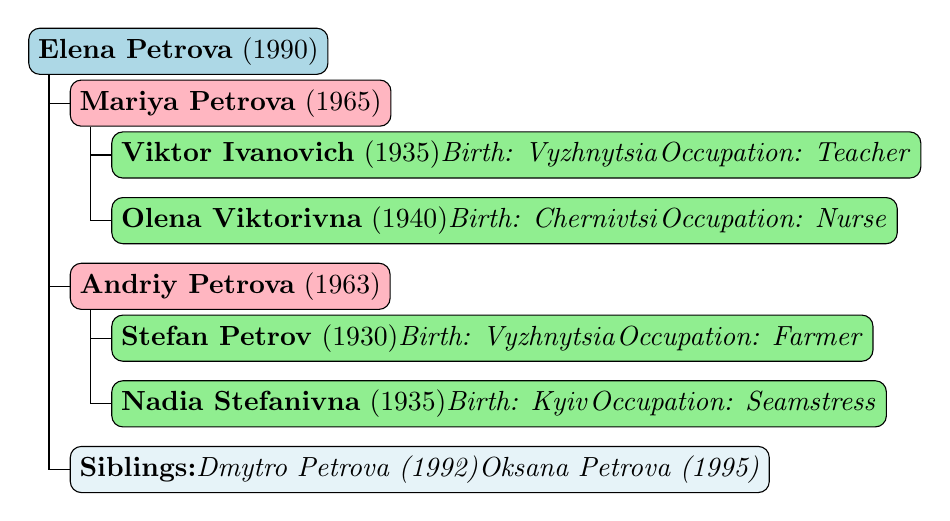What is the birth year of Elena Petrova? The table clearly shows that Elena Petrova was born in 1990.
Answer: 1990 Who are the parents of Elena Petrova? The parents listed for Elena Petrova are Mariya Petrova (1965) and Andriy Petrova (1963).
Answer: Mariya Petrova and Andriy Petrova What is the occupation of Viktor Ivanovich? The table specifies that Viktor Ivanovich is a teacher.
Answer: Teacher How many siblings does Elena have? The table indicates that Elena has two siblings: Dmytro Petrova (1992) and Oksana Petrova (1995), so the total is 2.
Answer: 2 Is Nadia Stefanivna from Vyzhnytsia? The table states that Nadia Stefanivna was born in Kyiv, which means she is not from Vyzhnytsia.
Answer: No What is the combined birth year of Elena and her siblings? Adding the birth years: 1990 (Elena) + 1992 (Dmytro) + 1995 (Oksana) = 5977. The combined birth year is 5977.
Answer: 5977 Who was born first, Viktor Ivanovich or Stefan Petrov? Viktor Ivanovich was born in 1935 and Stefan Petrov in 1930. Since 1930 is earlier than 1935, Stefan was born first.
Answer: Stefan Petrov How many generations are represented in the family tree? The tree shows 3 generations: Elena (1st generation), her parents (2nd generation), and her grandparents (3rd generation).
Answer: 3 generations What is the occupation of the parent with the oldest birth year? The oldest parent listed is Viktor Ivanovich, born in 1935, and he is a teacher. Therefore, the occupation is teacher.
Answer: Teacher 